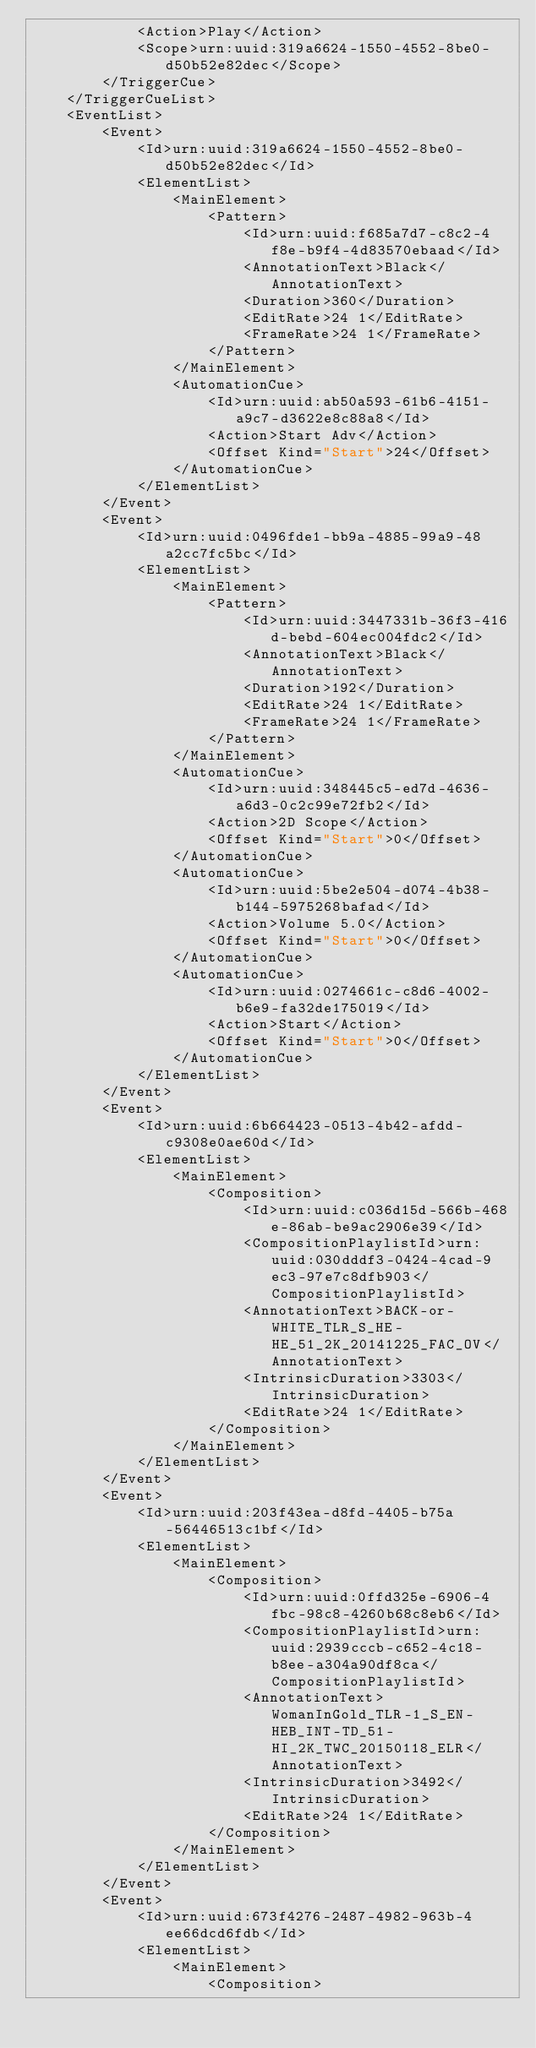Convert code to text. <code><loc_0><loc_0><loc_500><loc_500><_XML_>			<Action>Play</Action>
			<Scope>urn:uuid:319a6624-1550-4552-8be0-d50b52e82dec</Scope>
		</TriggerCue>
	</TriggerCueList>
	<EventList>
		<Event>
			<Id>urn:uuid:319a6624-1550-4552-8be0-d50b52e82dec</Id>
			<ElementList>
				<MainElement>
					<Pattern>
						<Id>urn:uuid:f685a7d7-c8c2-4f8e-b9f4-4d83570ebaad</Id>
						<AnnotationText>Black</AnnotationText>
						<Duration>360</Duration>
						<EditRate>24 1</EditRate>
						<FrameRate>24 1</FrameRate>
					</Pattern>
				</MainElement>
				<AutomationCue>
					<Id>urn:uuid:ab50a593-61b6-4151-a9c7-d3622e8c88a8</Id>
					<Action>Start Adv</Action>
					<Offset Kind="Start">24</Offset>
				</AutomationCue>
			</ElementList>
		</Event>
		<Event>
			<Id>urn:uuid:0496fde1-bb9a-4885-99a9-48a2cc7fc5bc</Id>
			<ElementList>
				<MainElement>
					<Pattern>
						<Id>urn:uuid:3447331b-36f3-416d-bebd-604ec004fdc2</Id>
						<AnnotationText>Black</AnnotationText>
						<Duration>192</Duration>
						<EditRate>24 1</EditRate>
						<FrameRate>24 1</FrameRate>
					</Pattern>
				</MainElement>
				<AutomationCue>
					<Id>urn:uuid:348445c5-ed7d-4636-a6d3-0c2c99e72fb2</Id>
					<Action>2D Scope</Action>
					<Offset Kind="Start">0</Offset>
				</AutomationCue>
				<AutomationCue>
					<Id>urn:uuid:5be2e504-d074-4b38-b144-5975268bafad</Id>
					<Action>Volume 5.0</Action>
					<Offset Kind="Start">0</Offset>
				</AutomationCue>
				<AutomationCue>
					<Id>urn:uuid:0274661c-c8d6-4002-b6e9-fa32de175019</Id>
					<Action>Start</Action>
					<Offset Kind="Start">0</Offset>
				</AutomationCue>
			</ElementList>
		</Event>
		<Event>
			<Id>urn:uuid:6b664423-0513-4b42-afdd-c9308e0ae60d</Id>
			<ElementList>
				<MainElement>
					<Composition>
						<Id>urn:uuid:c036d15d-566b-468e-86ab-be9ac2906e39</Id>
						<CompositionPlaylistId>urn:uuid:030dddf3-0424-4cad-9ec3-97e7c8dfb903</CompositionPlaylistId>
						<AnnotationText>BACK-or-WHITE_TLR_S_HE-HE_51_2K_20141225_FAC_OV</AnnotationText>
						<IntrinsicDuration>3303</IntrinsicDuration>
						<EditRate>24 1</EditRate>
					</Composition>
				</MainElement>
			</ElementList>
		</Event>
		<Event>
			<Id>urn:uuid:203f43ea-d8fd-4405-b75a-56446513c1bf</Id>
			<ElementList>
				<MainElement>
					<Composition>
						<Id>urn:uuid:0ffd325e-6906-4fbc-98c8-4260b68c8eb6</Id>
						<CompositionPlaylistId>urn:uuid:2939cccb-c652-4c18-b8ee-a304a90df8ca</CompositionPlaylistId>
						<AnnotationText>WomanInGold_TLR-1_S_EN-HEB_INT-TD_51-HI_2K_TWC_20150118_ELR</AnnotationText>
						<IntrinsicDuration>3492</IntrinsicDuration>
						<EditRate>24 1</EditRate>
					</Composition>
				</MainElement>
			</ElementList>
		</Event>
		<Event>
			<Id>urn:uuid:673f4276-2487-4982-963b-4ee66dcd6fdb</Id>
			<ElementList>
				<MainElement>
					<Composition></code> 